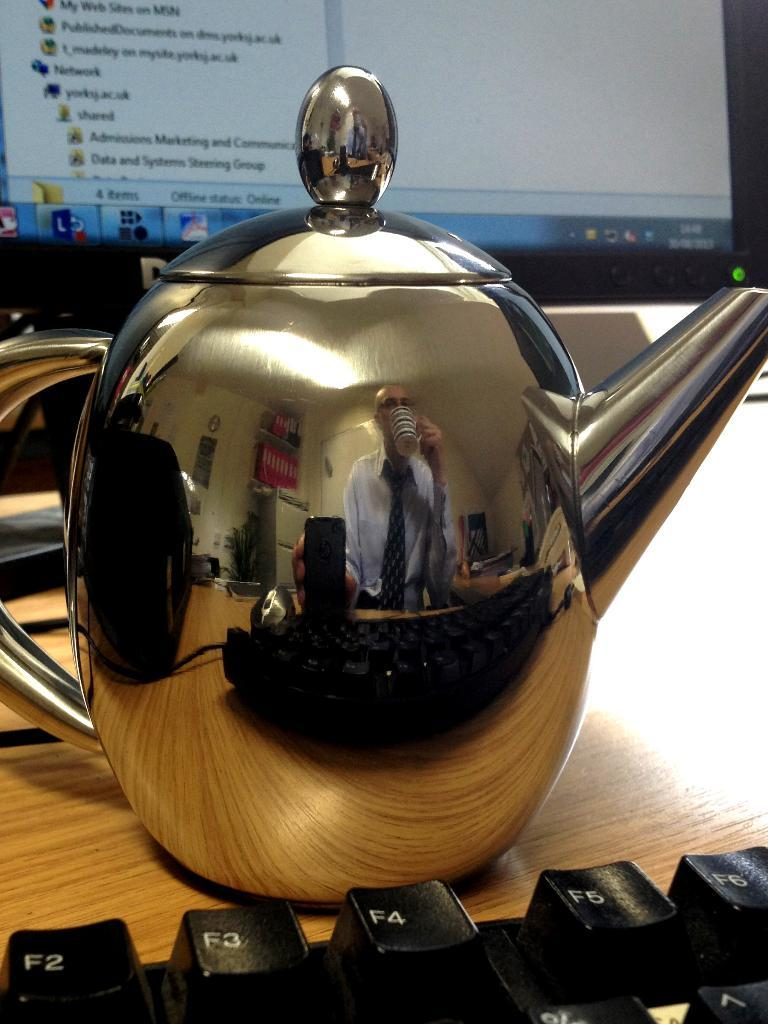What type of object is present on the table in the image? There is a kettle, keyboard, and monitor on the table in the image. What might the keyboard and monitor be used for? The keyboard and monitor are likely used for a computer or other electronic device. Can you describe the location of the kettle in relation to the other objects? The kettle is on the table alongside the keyboard and monitor. What type of plant is growing on the keyboard in the image? There is no plant growing on the keyboard in the image; the keyboard and monitor are electronic devices. 